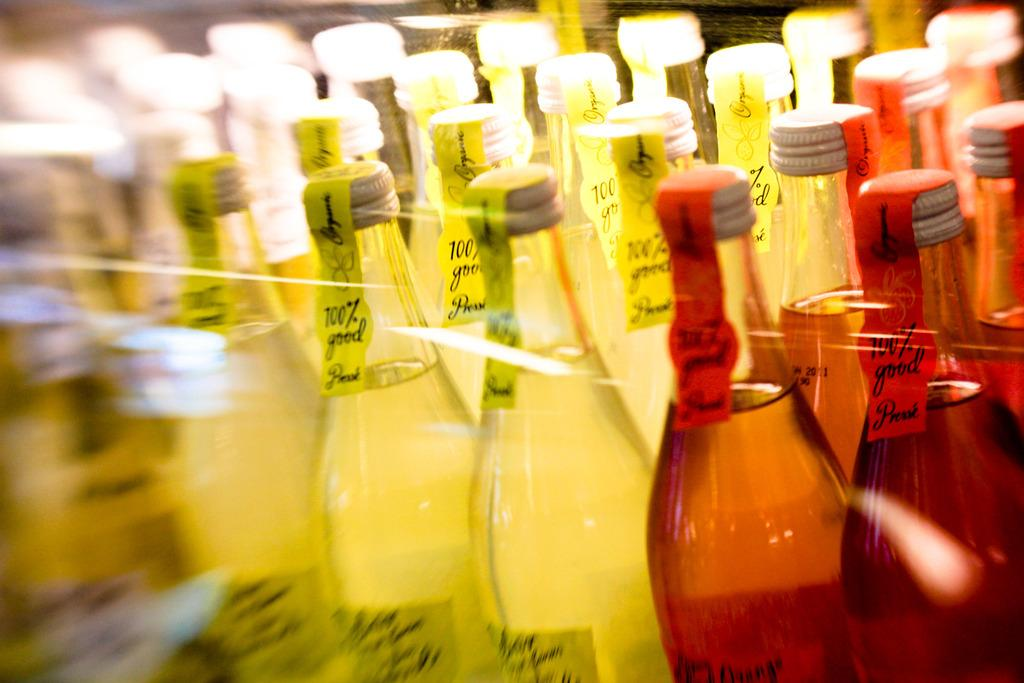What colors are the bottles in the image? There are yellow and red color bottles in the image. What can be seen on the bottles? The bottles have stickers on them. What is inside the bottles? The bottles contain a drink. How would you describe the quality of the image? The image is blurry. Can you see any smoke coming from the bottles in the image? There is no smoke present in the image; it features bottles with stickers and a drink inside. 